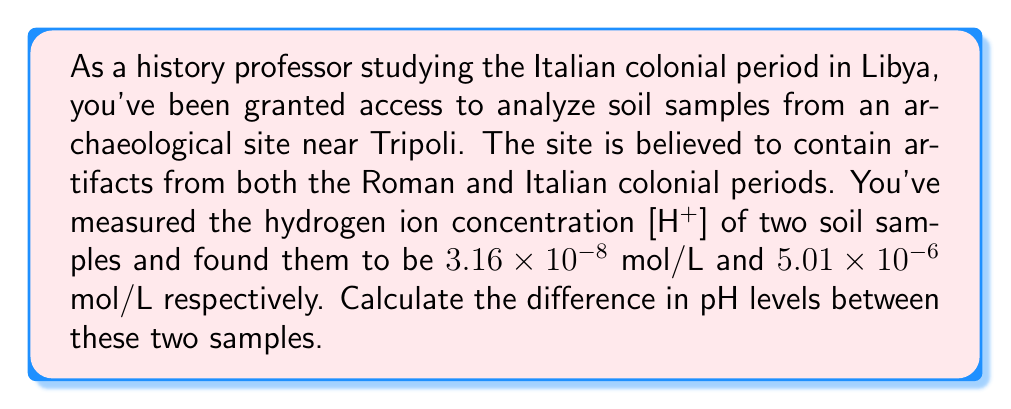Could you help me with this problem? To solve this problem, we need to follow these steps:

1) Recall the formula for pH:
   $$ pH = -\log_{10}[H^+] $$

2) Calculate the pH for the first sample:
   $$ pH_1 = -\log_{10}(3.16 \times 10^{-8}) $$
   $$ = -(\log_{10}3.16 + \log_{10}10^{-8}) $$
   $$ = -(0.4997 - 8) $$
   $$ = 7.5003 $$

3) Calculate the pH for the second sample:
   $$ pH_2 = -\log_{10}(5.01 \times 10^{-6}) $$
   $$ = -(\log_{10}5.01 + \log_{10}10^{-6}) $$
   $$ = -(0.6998 - 6) $$
   $$ = 5.3002 $$

4) Calculate the difference in pH levels:
   $$ \Delta pH = pH_1 - pH_2 $$
   $$ = 7.5003 - 5.3002 $$
   $$ = 2.2001 $$

The difference in pH levels between the two samples is approximately 2.20.
Answer: 2.20 